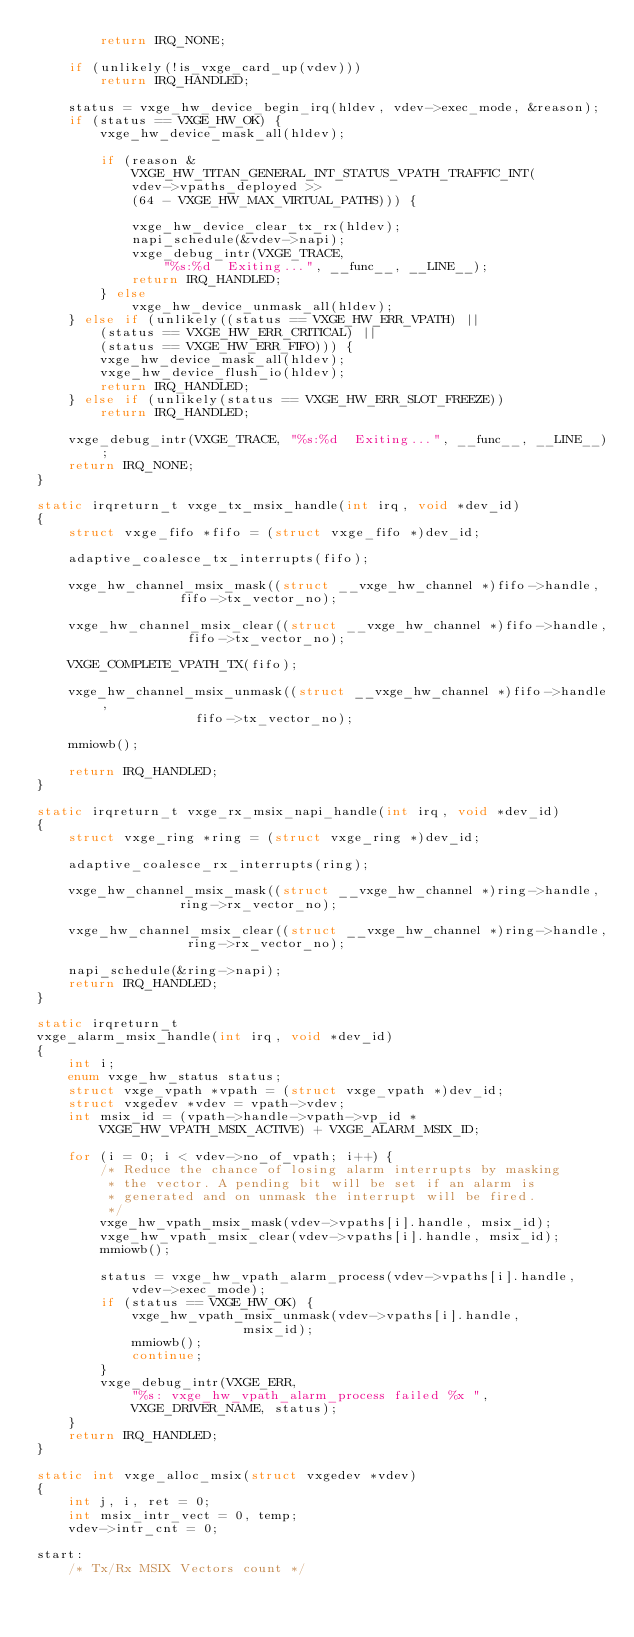Convert code to text. <code><loc_0><loc_0><loc_500><loc_500><_C_>		return IRQ_NONE;

	if (unlikely(!is_vxge_card_up(vdev)))
		return IRQ_HANDLED;

	status = vxge_hw_device_begin_irq(hldev, vdev->exec_mode, &reason);
	if (status == VXGE_HW_OK) {
		vxge_hw_device_mask_all(hldev);

		if (reason &
			VXGE_HW_TITAN_GENERAL_INT_STATUS_VPATH_TRAFFIC_INT(
			vdev->vpaths_deployed >>
			(64 - VXGE_HW_MAX_VIRTUAL_PATHS))) {

			vxge_hw_device_clear_tx_rx(hldev);
			napi_schedule(&vdev->napi);
			vxge_debug_intr(VXGE_TRACE,
				"%s:%d  Exiting...", __func__, __LINE__);
			return IRQ_HANDLED;
		} else
			vxge_hw_device_unmask_all(hldev);
	} else if (unlikely((status == VXGE_HW_ERR_VPATH) ||
		(status == VXGE_HW_ERR_CRITICAL) ||
		(status == VXGE_HW_ERR_FIFO))) {
		vxge_hw_device_mask_all(hldev);
		vxge_hw_device_flush_io(hldev);
		return IRQ_HANDLED;
	} else if (unlikely(status == VXGE_HW_ERR_SLOT_FREEZE))
		return IRQ_HANDLED;

	vxge_debug_intr(VXGE_TRACE, "%s:%d  Exiting...", __func__, __LINE__);
	return IRQ_NONE;
}

static irqreturn_t vxge_tx_msix_handle(int irq, void *dev_id)
{
	struct vxge_fifo *fifo = (struct vxge_fifo *)dev_id;

	adaptive_coalesce_tx_interrupts(fifo);

	vxge_hw_channel_msix_mask((struct __vxge_hw_channel *)fifo->handle,
				  fifo->tx_vector_no);

	vxge_hw_channel_msix_clear((struct __vxge_hw_channel *)fifo->handle,
				   fifo->tx_vector_no);

	VXGE_COMPLETE_VPATH_TX(fifo);

	vxge_hw_channel_msix_unmask((struct __vxge_hw_channel *)fifo->handle,
				    fifo->tx_vector_no);

	mmiowb();

	return IRQ_HANDLED;
}

static irqreturn_t vxge_rx_msix_napi_handle(int irq, void *dev_id)
{
	struct vxge_ring *ring = (struct vxge_ring *)dev_id;

	adaptive_coalesce_rx_interrupts(ring);

	vxge_hw_channel_msix_mask((struct __vxge_hw_channel *)ring->handle,
				  ring->rx_vector_no);

	vxge_hw_channel_msix_clear((struct __vxge_hw_channel *)ring->handle,
				   ring->rx_vector_no);

	napi_schedule(&ring->napi);
	return IRQ_HANDLED;
}

static irqreturn_t
vxge_alarm_msix_handle(int irq, void *dev_id)
{
	int i;
	enum vxge_hw_status status;
	struct vxge_vpath *vpath = (struct vxge_vpath *)dev_id;
	struct vxgedev *vdev = vpath->vdev;
	int msix_id = (vpath->handle->vpath->vp_id *
		VXGE_HW_VPATH_MSIX_ACTIVE) + VXGE_ALARM_MSIX_ID;

	for (i = 0; i < vdev->no_of_vpath; i++) {
		/* Reduce the chance of losing alarm interrupts by masking
		 * the vector. A pending bit will be set if an alarm is
		 * generated and on unmask the interrupt will be fired.
		 */
		vxge_hw_vpath_msix_mask(vdev->vpaths[i].handle, msix_id);
		vxge_hw_vpath_msix_clear(vdev->vpaths[i].handle, msix_id);
		mmiowb();

		status = vxge_hw_vpath_alarm_process(vdev->vpaths[i].handle,
			vdev->exec_mode);
		if (status == VXGE_HW_OK) {
			vxge_hw_vpath_msix_unmask(vdev->vpaths[i].handle,
						  msix_id);
			mmiowb();
			continue;
		}
		vxge_debug_intr(VXGE_ERR,
			"%s: vxge_hw_vpath_alarm_process failed %x ",
			VXGE_DRIVER_NAME, status);
	}
	return IRQ_HANDLED;
}

static int vxge_alloc_msix(struct vxgedev *vdev)
{
	int j, i, ret = 0;
	int msix_intr_vect = 0, temp;
	vdev->intr_cnt = 0;

start:
	/* Tx/Rx MSIX Vectors count */</code> 